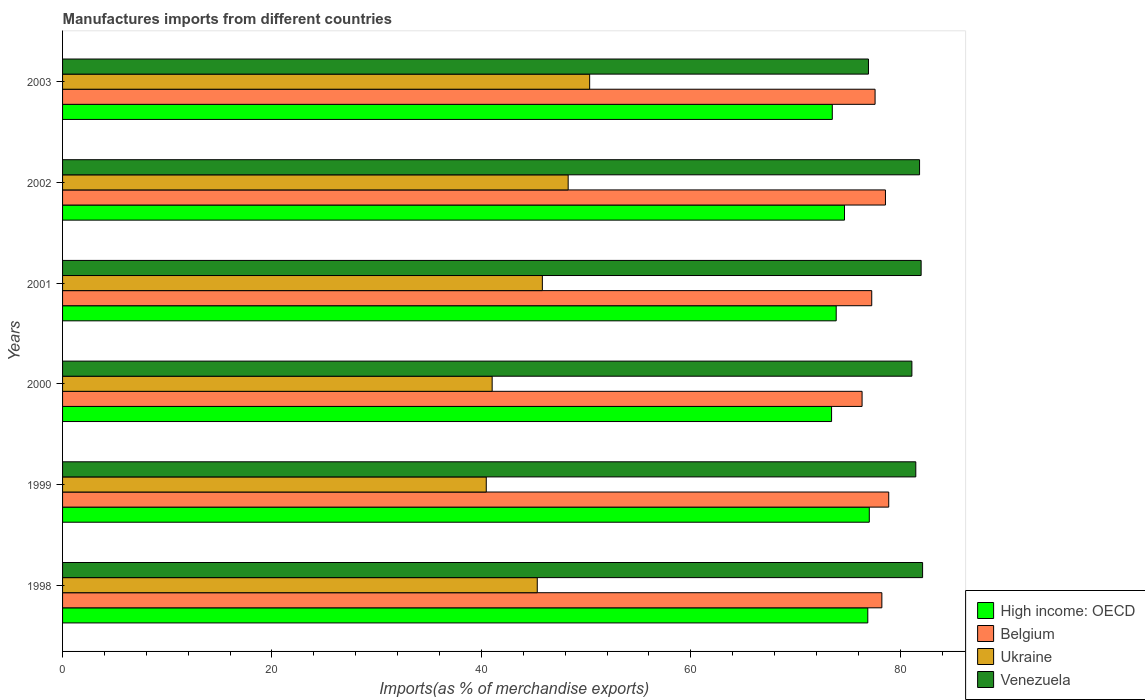What is the label of the 4th group of bars from the top?
Keep it short and to the point. 2000. What is the percentage of imports to different countries in Belgium in 2001?
Give a very brief answer. 77.28. Across all years, what is the maximum percentage of imports to different countries in Venezuela?
Ensure brevity in your answer.  82.14. Across all years, what is the minimum percentage of imports to different countries in Ukraine?
Make the answer very short. 40.46. What is the total percentage of imports to different countries in High income: OECD in the graph?
Your answer should be very brief. 449.47. What is the difference between the percentage of imports to different countries in Venezuela in 2001 and that in 2003?
Offer a terse response. 5.03. What is the difference between the percentage of imports to different countries in High income: OECD in 2001 and the percentage of imports to different countries in Belgium in 2002?
Provide a short and direct response. -4.71. What is the average percentage of imports to different countries in Belgium per year?
Give a very brief answer. 77.83. In the year 2002, what is the difference between the percentage of imports to different countries in Ukraine and percentage of imports to different countries in Belgium?
Ensure brevity in your answer.  -30.3. In how many years, is the percentage of imports to different countries in Belgium greater than 52 %?
Provide a succinct answer. 6. What is the ratio of the percentage of imports to different countries in Ukraine in 2001 to that in 2003?
Keep it short and to the point. 0.91. What is the difference between the highest and the second highest percentage of imports to different countries in Belgium?
Give a very brief answer. 0.31. What is the difference between the highest and the lowest percentage of imports to different countries in Belgium?
Your answer should be compact. 2.55. Is it the case that in every year, the sum of the percentage of imports to different countries in High income: OECD and percentage of imports to different countries in Venezuela is greater than the sum of percentage of imports to different countries in Ukraine and percentage of imports to different countries in Belgium?
Provide a succinct answer. No. What does the 1st bar from the bottom in 2000 represents?
Provide a short and direct response. High income: OECD. Is it the case that in every year, the sum of the percentage of imports to different countries in Ukraine and percentage of imports to different countries in Belgium is greater than the percentage of imports to different countries in Venezuela?
Keep it short and to the point. Yes. How many years are there in the graph?
Your response must be concise. 6. Does the graph contain any zero values?
Keep it short and to the point. No. Does the graph contain grids?
Provide a short and direct response. No. Where does the legend appear in the graph?
Provide a short and direct response. Bottom right. What is the title of the graph?
Provide a short and direct response. Manufactures imports from different countries. Does "Barbados" appear as one of the legend labels in the graph?
Offer a terse response. No. What is the label or title of the X-axis?
Offer a very short reply. Imports(as % of merchandise exports). What is the label or title of the Y-axis?
Make the answer very short. Years. What is the Imports(as % of merchandise exports) of High income: OECD in 1998?
Offer a terse response. 76.9. What is the Imports(as % of merchandise exports) in Belgium in 1998?
Your answer should be compact. 78.25. What is the Imports(as % of merchandise exports) in Ukraine in 1998?
Provide a succinct answer. 45.34. What is the Imports(as % of merchandise exports) in Venezuela in 1998?
Provide a succinct answer. 82.14. What is the Imports(as % of merchandise exports) of High income: OECD in 1999?
Your answer should be very brief. 77.05. What is the Imports(as % of merchandise exports) of Belgium in 1999?
Keep it short and to the point. 78.9. What is the Imports(as % of merchandise exports) of Ukraine in 1999?
Make the answer very short. 40.46. What is the Imports(as % of merchandise exports) in Venezuela in 1999?
Your response must be concise. 81.49. What is the Imports(as % of merchandise exports) in High income: OECD in 2000?
Give a very brief answer. 73.44. What is the Imports(as % of merchandise exports) in Belgium in 2000?
Your response must be concise. 76.36. What is the Imports(as % of merchandise exports) of Ukraine in 2000?
Your answer should be compact. 41.03. What is the Imports(as % of merchandise exports) in Venezuela in 2000?
Offer a very short reply. 81.12. What is the Imports(as % of merchandise exports) of High income: OECD in 2001?
Provide a succinct answer. 73.89. What is the Imports(as % of merchandise exports) of Belgium in 2001?
Provide a succinct answer. 77.28. What is the Imports(as % of merchandise exports) in Ukraine in 2001?
Make the answer very short. 45.82. What is the Imports(as % of merchandise exports) of Venezuela in 2001?
Your answer should be compact. 82. What is the Imports(as % of merchandise exports) in High income: OECD in 2002?
Your response must be concise. 74.68. What is the Imports(as % of merchandise exports) in Belgium in 2002?
Your response must be concise. 78.59. What is the Imports(as % of merchandise exports) of Ukraine in 2002?
Your answer should be compact. 48.29. What is the Imports(as % of merchandise exports) of Venezuela in 2002?
Provide a short and direct response. 81.85. What is the Imports(as % of merchandise exports) of High income: OECD in 2003?
Offer a very short reply. 73.51. What is the Imports(as % of merchandise exports) in Belgium in 2003?
Offer a terse response. 77.6. What is the Imports(as % of merchandise exports) in Ukraine in 2003?
Your answer should be compact. 50.34. What is the Imports(as % of merchandise exports) of Venezuela in 2003?
Offer a very short reply. 76.97. Across all years, what is the maximum Imports(as % of merchandise exports) in High income: OECD?
Give a very brief answer. 77.05. Across all years, what is the maximum Imports(as % of merchandise exports) of Belgium?
Your answer should be very brief. 78.9. Across all years, what is the maximum Imports(as % of merchandise exports) in Ukraine?
Keep it short and to the point. 50.34. Across all years, what is the maximum Imports(as % of merchandise exports) in Venezuela?
Your answer should be compact. 82.14. Across all years, what is the minimum Imports(as % of merchandise exports) of High income: OECD?
Provide a succinct answer. 73.44. Across all years, what is the minimum Imports(as % of merchandise exports) in Belgium?
Make the answer very short. 76.36. Across all years, what is the minimum Imports(as % of merchandise exports) in Ukraine?
Provide a short and direct response. 40.46. Across all years, what is the minimum Imports(as % of merchandise exports) of Venezuela?
Offer a very short reply. 76.97. What is the total Imports(as % of merchandise exports) of High income: OECD in the graph?
Offer a very short reply. 449.47. What is the total Imports(as % of merchandise exports) in Belgium in the graph?
Provide a succinct answer. 466.98. What is the total Imports(as % of merchandise exports) in Ukraine in the graph?
Offer a terse response. 271.28. What is the total Imports(as % of merchandise exports) of Venezuela in the graph?
Your answer should be very brief. 485.56. What is the difference between the Imports(as % of merchandise exports) of High income: OECD in 1998 and that in 1999?
Your answer should be compact. -0.14. What is the difference between the Imports(as % of merchandise exports) in Belgium in 1998 and that in 1999?
Give a very brief answer. -0.66. What is the difference between the Imports(as % of merchandise exports) in Ukraine in 1998 and that in 1999?
Offer a very short reply. 4.87. What is the difference between the Imports(as % of merchandise exports) of Venezuela in 1998 and that in 1999?
Your answer should be compact. 0.65. What is the difference between the Imports(as % of merchandise exports) of High income: OECD in 1998 and that in 2000?
Provide a short and direct response. 3.46. What is the difference between the Imports(as % of merchandise exports) of Belgium in 1998 and that in 2000?
Give a very brief answer. 1.89. What is the difference between the Imports(as % of merchandise exports) of Ukraine in 1998 and that in 2000?
Your answer should be very brief. 4.31. What is the difference between the Imports(as % of merchandise exports) of Venezuela in 1998 and that in 2000?
Your answer should be compact. 1.02. What is the difference between the Imports(as % of merchandise exports) of High income: OECD in 1998 and that in 2001?
Offer a terse response. 3.02. What is the difference between the Imports(as % of merchandise exports) of Belgium in 1998 and that in 2001?
Your answer should be compact. 0.97. What is the difference between the Imports(as % of merchandise exports) of Ukraine in 1998 and that in 2001?
Your answer should be compact. -0.49. What is the difference between the Imports(as % of merchandise exports) of Venezuela in 1998 and that in 2001?
Provide a short and direct response. 0.14. What is the difference between the Imports(as % of merchandise exports) in High income: OECD in 1998 and that in 2002?
Give a very brief answer. 2.23. What is the difference between the Imports(as % of merchandise exports) in Belgium in 1998 and that in 2002?
Offer a terse response. -0.34. What is the difference between the Imports(as % of merchandise exports) of Ukraine in 1998 and that in 2002?
Your answer should be compact. -2.95. What is the difference between the Imports(as % of merchandise exports) in Venezuela in 1998 and that in 2002?
Your response must be concise. 0.29. What is the difference between the Imports(as % of merchandise exports) in High income: OECD in 1998 and that in 2003?
Your answer should be very brief. 3.39. What is the difference between the Imports(as % of merchandise exports) in Belgium in 1998 and that in 2003?
Provide a succinct answer. 0.65. What is the difference between the Imports(as % of merchandise exports) in Ukraine in 1998 and that in 2003?
Offer a terse response. -5. What is the difference between the Imports(as % of merchandise exports) of Venezuela in 1998 and that in 2003?
Your answer should be compact. 5.17. What is the difference between the Imports(as % of merchandise exports) of High income: OECD in 1999 and that in 2000?
Make the answer very short. 3.6. What is the difference between the Imports(as % of merchandise exports) in Belgium in 1999 and that in 2000?
Your answer should be compact. 2.55. What is the difference between the Imports(as % of merchandise exports) of Ukraine in 1999 and that in 2000?
Your answer should be very brief. -0.56. What is the difference between the Imports(as % of merchandise exports) in Venezuela in 1999 and that in 2000?
Your answer should be compact. 0.37. What is the difference between the Imports(as % of merchandise exports) in High income: OECD in 1999 and that in 2001?
Offer a very short reply. 3.16. What is the difference between the Imports(as % of merchandise exports) of Belgium in 1999 and that in 2001?
Make the answer very short. 1.62. What is the difference between the Imports(as % of merchandise exports) of Ukraine in 1999 and that in 2001?
Provide a short and direct response. -5.36. What is the difference between the Imports(as % of merchandise exports) in Venezuela in 1999 and that in 2001?
Provide a succinct answer. -0.51. What is the difference between the Imports(as % of merchandise exports) of High income: OECD in 1999 and that in 2002?
Your response must be concise. 2.37. What is the difference between the Imports(as % of merchandise exports) of Belgium in 1999 and that in 2002?
Provide a succinct answer. 0.31. What is the difference between the Imports(as % of merchandise exports) of Ukraine in 1999 and that in 2002?
Keep it short and to the point. -7.82. What is the difference between the Imports(as % of merchandise exports) of Venezuela in 1999 and that in 2002?
Ensure brevity in your answer.  -0.36. What is the difference between the Imports(as % of merchandise exports) in High income: OECD in 1999 and that in 2003?
Keep it short and to the point. 3.53. What is the difference between the Imports(as % of merchandise exports) in Belgium in 1999 and that in 2003?
Offer a very short reply. 1.3. What is the difference between the Imports(as % of merchandise exports) in Ukraine in 1999 and that in 2003?
Make the answer very short. -9.87. What is the difference between the Imports(as % of merchandise exports) of Venezuela in 1999 and that in 2003?
Offer a very short reply. 4.52. What is the difference between the Imports(as % of merchandise exports) of High income: OECD in 2000 and that in 2001?
Your answer should be compact. -0.44. What is the difference between the Imports(as % of merchandise exports) of Belgium in 2000 and that in 2001?
Provide a succinct answer. -0.92. What is the difference between the Imports(as % of merchandise exports) in Ukraine in 2000 and that in 2001?
Offer a terse response. -4.8. What is the difference between the Imports(as % of merchandise exports) in Venezuela in 2000 and that in 2001?
Provide a short and direct response. -0.88. What is the difference between the Imports(as % of merchandise exports) of High income: OECD in 2000 and that in 2002?
Offer a terse response. -1.23. What is the difference between the Imports(as % of merchandise exports) in Belgium in 2000 and that in 2002?
Keep it short and to the point. -2.23. What is the difference between the Imports(as % of merchandise exports) of Ukraine in 2000 and that in 2002?
Provide a succinct answer. -7.26. What is the difference between the Imports(as % of merchandise exports) of Venezuela in 2000 and that in 2002?
Provide a succinct answer. -0.73. What is the difference between the Imports(as % of merchandise exports) of High income: OECD in 2000 and that in 2003?
Provide a short and direct response. -0.07. What is the difference between the Imports(as % of merchandise exports) in Belgium in 2000 and that in 2003?
Your answer should be very brief. -1.24. What is the difference between the Imports(as % of merchandise exports) of Ukraine in 2000 and that in 2003?
Offer a very short reply. -9.31. What is the difference between the Imports(as % of merchandise exports) in Venezuela in 2000 and that in 2003?
Make the answer very short. 4.15. What is the difference between the Imports(as % of merchandise exports) in High income: OECD in 2001 and that in 2002?
Your response must be concise. -0.79. What is the difference between the Imports(as % of merchandise exports) in Belgium in 2001 and that in 2002?
Ensure brevity in your answer.  -1.31. What is the difference between the Imports(as % of merchandise exports) of Ukraine in 2001 and that in 2002?
Your answer should be compact. -2.47. What is the difference between the Imports(as % of merchandise exports) in Venezuela in 2001 and that in 2002?
Your answer should be very brief. 0.15. What is the difference between the Imports(as % of merchandise exports) in High income: OECD in 2001 and that in 2003?
Offer a terse response. 0.37. What is the difference between the Imports(as % of merchandise exports) of Belgium in 2001 and that in 2003?
Your answer should be very brief. -0.32. What is the difference between the Imports(as % of merchandise exports) of Ukraine in 2001 and that in 2003?
Your response must be concise. -4.52. What is the difference between the Imports(as % of merchandise exports) of Venezuela in 2001 and that in 2003?
Provide a succinct answer. 5.03. What is the difference between the Imports(as % of merchandise exports) in High income: OECD in 2002 and that in 2003?
Your answer should be compact. 1.16. What is the difference between the Imports(as % of merchandise exports) of Ukraine in 2002 and that in 2003?
Your response must be concise. -2.05. What is the difference between the Imports(as % of merchandise exports) of Venezuela in 2002 and that in 2003?
Your answer should be very brief. 4.88. What is the difference between the Imports(as % of merchandise exports) of High income: OECD in 1998 and the Imports(as % of merchandise exports) of Belgium in 1999?
Your answer should be compact. -2. What is the difference between the Imports(as % of merchandise exports) in High income: OECD in 1998 and the Imports(as % of merchandise exports) in Ukraine in 1999?
Make the answer very short. 36.44. What is the difference between the Imports(as % of merchandise exports) in High income: OECD in 1998 and the Imports(as % of merchandise exports) in Venezuela in 1999?
Provide a succinct answer. -4.58. What is the difference between the Imports(as % of merchandise exports) of Belgium in 1998 and the Imports(as % of merchandise exports) of Ukraine in 1999?
Provide a short and direct response. 37.78. What is the difference between the Imports(as % of merchandise exports) in Belgium in 1998 and the Imports(as % of merchandise exports) in Venezuela in 1999?
Ensure brevity in your answer.  -3.24. What is the difference between the Imports(as % of merchandise exports) of Ukraine in 1998 and the Imports(as % of merchandise exports) of Venezuela in 1999?
Offer a terse response. -36.15. What is the difference between the Imports(as % of merchandise exports) of High income: OECD in 1998 and the Imports(as % of merchandise exports) of Belgium in 2000?
Provide a succinct answer. 0.55. What is the difference between the Imports(as % of merchandise exports) of High income: OECD in 1998 and the Imports(as % of merchandise exports) of Ukraine in 2000?
Keep it short and to the point. 35.88. What is the difference between the Imports(as % of merchandise exports) of High income: OECD in 1998 and the Imports(as % of merchandise exports) of Venezuela in 2000?
Make the answer very short. -4.21. What is the difference between the Imports(as % of merchandise exports) of Belgium in 1998 and the Imports(as % of merchandise exports) of Ukraine in 2000?
Provide a short and direct response. 37.22. What is the difference between the Imports(as % of merchandise exports) of Belgium in 1998 and the Imports(as % of merchandise exports) of Venezuela in 2000?
Keep it short and to the point. -2.87. What is the difference between the Imports(as % of merchandise exports) in Ukraine in 1998 and the Imports(as % of merchandise exports) in Venezuela in 2000?
Offer a very short reply. -35.78. What is the difference between the Imports(as % of merchandise exports) in High income: OECD in 1998 and the Imports(as % of merchandise exports) in Belgium in 2001?
Keep it short and to the point. -0.38. What is the difference between the Imports(as % of merchandise exports) in High income: OECD in 1998 and the Imports(as % of merchandise exports) in Ukraine in 2001?
Keep it short and to the point. 31.08. What is the difference between the Imports(as % of merchandise exports) in High income: OECD in 1998 and the Imports(as % of merchandise exports) in Venezuela in 2001?
Make the answer very short. -5.09. What is the difference between the Imports(as % of merchandise exports) in Belgium in 1998 and the Imports(as % of merchandise exports) in Ukraine in 2001?
Your answer should be very brief. 32.42. What is the difference between the Imports(as % of merchandise exports) in Belgium in 1998 and the Imports(as % of merchandise exports) in Venezuela in 2001?
Give a very brief answer. -3.75. What is the difference between the Imports(as % of merchandise exports) in Ukraine in 1998 and the Imports(as % of merchandise exports) in Venezuela in 2001?
Provide a succinct answer. -36.66. What is the difference between the Imports(as % of merchandise exports) in High income: OECD in 1998 and the Imports(as % of merchandise exports) in Belgium in 2002?
Your answer should be compact. -1.69. What is the difference between the Imports(as % of merchandise exports) of High income: OECD in 1998 and the Imports(as % of merchandise exports) of Ukraine in 2002?
Your answer should be compact. 28.62. What is the difference between the Imports(as % of merchandise exports) in High income: OECD in 1998 and the Imports(as % of merchandise exports) in Venezuela in 2002?
Give a very brief answer. -4.94. What is the difference between the Imports(as % of merchandise exports) in Belgium in 1998 and the Imports(as % of merchandise exports) in Ukraine in 2002?
Keep it short and to the point. 29.96. What is the difference between the Imports(as % of merchandise exports) in Belgium in 1998 and the Imports(as % of merchandise exports) in Venezuela in 2002?
Offer a very short reply. -3.6. What is the difference between the Imports(as % of merchandise exports) in Ukraine in 1998 and the Imports(as % of merchandise exports) in Venezuela in 2002?
Your response must be concise. -36.51. What is the difference between the Imports(as % of merchandise exports) of High income: OECD in 1998 and the Imports(as % of merchandise exports) of Belgium in 2003?
Your answer should be compact. -0.7. What is the difference between the Imports(as % of merchandise exports) of High income: OECD in 1998 and the Imports(as % of merchandise exports) of Ukraine in 2003?
Your answer should be very brief. 26.57. What is the difference between the Imports(as % of merchandise exports) in High income: OECD in 1998 and the Imports(as % of merchandise exports) in Venezuela in 2003?
Provide a succinct answer. -0.06. What is the difference between the Imports(as % of merchandise exports) in Belgium in 1998 and the Imports(as % of merchandise exports) in Ukraine in 2003?
Your answer should be compact. 27.91. What is the difference between the Imports(as % of merchandise exports) in Belgium in 1998 and the Imports(as % of merchandise exports) in Venezuela in 2003?
Keep it short and to the point. 1.28. What is the difference between the Imports(as % of merchandise exports) in Ukraine in 1998 and the Imports(as % of merchandise exports) in Venezuela in 2003?
Your answer should be very brief. -31.63. What is the difference between the Imports(as % of merchandise exports) in High income: OECD in 1999 and the Imports(as % of merchandise exports) in Belgium in 2000?
Provide a short and direct response. 0.69. What is the difference between the Imports(as % of merchandise exports) in High income: OECD in 1999 and the Imports(as % of merchandise exports) in Ukraine in 2000?
Offer a very short reply. 36.02. What is the difference between the Imports(as % of merchandise exports) in High income: OECD in 1999 and the Imports(as % of merchandise exports) in Venezuela in 2000?
Provide a short and direct response. -4.07. What is the difference between the Imports(as % of merchandise exports) in Belgium in 1999 and the Imports(as % of merchandise exports) in Ukraine in 2000?
Offer a very short reply. 37.88. What is the difference between the Imports(as % of merchandise exports) in Belgium in 1999 and the Imports(as % of merchandise exports) in Venezuela in 2000?
Your answer should be compact. -2.21. What is the difference between the Imports(as % of merchandise exports) of Ukraine in 1999 and the Imports(as % of merchandise exports) of Venezuela in 2000?
Offer a very short reply. -40.65. What is the difference between the Imports(as % of merchandise exports) of High income: OECD in 1999 and the Imports(as % of merchandise exports) of Belgium in 2001?
Give a very brief answer. -0.23. What is the difference between the Imports(as % of merchandise exports) in High income: OECD in 1999 and the Imports(as % of merchandise exports) in Ukraine in 2001?
Give a very brief answer. 31.22. What is the difference between the Imports(as % of merchandise exports) of High income: OECD in 1999 and the Imports(as % of merchandise exports) of Venezuela in 2001?
Your answer should be compact. -4.95. What is the difference between the Imports(as % of merchandise exports) of Belgium in 1999 and the Imports(as % of merchandise exports) of Ukraine in 2001?
Give a very brief answer. 33.08. What is the difference between the Imports(as % of merchandise exports) of Belgium in 1999 and the Imports(as % of merchandise exports) of Venezuela in 2001?
Make the answer very short. -3.1. What is the difference between the Imports(as % of merchandise exports) of Ukraine in 1999 and the Imports(as % of merchandise exports) of Venezuela in 2001?
Make the answer very short. -41.53. What is the difference between the Imports(as % of merchandise exports) in High income: OECD in 1999 and the Imports(as % of merchandise exports) in Belgium in 2002?
Provide a short and direct response. -1.54. What is the difference between the Imports(as % of merchandise exports) of High income: OECD in 1999 and the Imports(as % of merchandise exports) of Ukraine in 2002?
Make the answer very short. 28.76. What is the difference between the Imports(as % of merchandise exports) of High income: OECD in 1999 and the Imports(as % of merchandise exports) of Venezuela in 2002?
Your answer should be very brief. -4.8. What is the difference between the Imports(as % of merchandise exports) of Belgium in 1999 and the Imports(as % of merchandise exports) of Ukraine in 2002?
Your response must be concise. 30.61. What is the difference between the Imports(as % of merchandise exports) in Belgium in 1999 and the Imports(as % of merchandise exports) in Venezuela in 2002?
Your response must be concise. -2.94. What is the difference between the Imports(as % of merchandise exports) in Ukraine in 1999 and the Imports(as % of merchandise exports) in Venezuela in 2002?
Your answer should be compact. -41.38. What is the difference between the Imports(as % of merchandise exports) of High income: OECD in 1999 and the Imports(as % of merchandise exports) of Belgium in 2003?
Offer a terse response. -0.55. What is the difference between the Imports(as % of merchandise exports) in High income: OECD in 1999 and the Imports(as % of merchandise exports) in Ukraine in 2003?
Ensure brevity in your answer.  26.71. What is the difference between the Imports(as % of merchandise exports) of High income: OECD in 1999 and the Imports(as % of merchandise exports) of Venezuela in 2003?
Your response must be concise. 0.08. What is the difference between the Imports(as % of merchandise exports) in Belgium in 1999 and the Imports(as % of merchandise exports) in Ukraine in 2003?
Your answer should be compact. 28.56. What is the difference between the Imports(as % of merchandise exports) in Belgium in 1999 and the Imports(as % of merchandise exports) in Venezuela in 2003?
Your answer should be compact. 1.94. What is the difference between the Imports(as % of merchandise exports) of Ukraine in 1999 and the Imports(as % of merchandise exports) of Venezuela in 2003?
Ensure brevity in your answer.  -36.5. What is the difference between the Imports(as % of merchandise exports) in High income: OECD in 2000 and the Imports(as % of merchandise exports) in Belgium in 2001?
Offer a very short reply. -3.84. What is the difference between the Imports(as % of merchandise exports) in High income: OECD in 2000 and the Imports(as % of merchandise exports) in Ukraine in 2001?
Provide a succinct answer. 27.62. What is the difference between the Imports(as % of merchandise exports) in High income: OECD in 2000 and the Imports(as % of merchandise exports) in Venezuela in 2001?
Offer a very short reply. -8.55. What is the difference between the Imports(as % of merchandise exports) of Belgium in 2000 and the Imports(as % of merchandise exports) of Ukraine in 2001?
Provide a succinct answer. 30.53. What is the difference between the Imports(as % of merchandise exports) of Belgium in 2000 and the Imports(as % of merchandise exports) of Venezuela in 2001?
Offer a terse response. -5.64. What is the difference between the Imports(as % of merchandise exports) of Ukraine in 2000 and the Imports(as % of merchandise exports) of Venezuela in 2001?
Your answer should be very brief. -40.97. What is the difference between the Imports(as % of merchandise exports) of High income: OECD in 2000 and the Imports(as % of merchandise exports) of Belgium in 2002?
Provide a succinct answer. -5.15. What is the difference between the Imports(as % of merchandise exports) in High income: OECD in 2000 and the Imports(as % of merchandise exports) in Ukraine in 2002?
Provide a short and direct response. 25.16. What is the difference between the Imports(as % of merchandise exports) in High income: OECD in 2000 and the Imports(as % of merchandise exports) in Venezuela in 2002?
Provide a short and direct response. -8.4. What is the difference between the Imports(as % of merchandise exports) in Belgium in 2000 and the Imports(as % of merchandise exports) in Ukraine in 2002?
Provide a succinct answer. 28.07. What is the difference between the Imports(as % of merchandise exports) of Belgium in 2000 and the Imports(as % of merchandise exports) of Venezuela in 2002?
Keep it short and to the point. -5.49. What is the difference between the Imports(as % of merchandise exports) in Ukraine in 2000 and the Imports(as % of merchandise exports) in Venezuela in 2002?
Your answer should be very brief. -40.82. What is the difference between the Imports(as % of merchandise exports) in High income: OECD in 2000 and the Imports(as % of merchandise exports) in Belgium in 2003?
Offer a very short reply. -4.16. What is the difference between the Imports(as % of merchandise exports) in High income: OECD in 2000 and the Imports(as % of merchandise exports) in Ukraine in 2003?
Your answer should be very brief. 23.1. What is the difference between the Imports(as % of merchandise exports) in High income: OECD in 2000 and the Imports(as % of merchandise exports) in Venezuela in 2003?
Make the answer very short. -3.52. What is the difference between the Imports(as % of merchandise exports) of Belgium in 2000 and the Imports(as % of merchandise exports) of Ukraine in 2003?
Offer a very short reply. 26.02. What is the difference between the Imports(as % of merchandise exports) of Belgium in 2000 and the Imports(as % of merchandise exports) of Venezuela in 2003?
Ensure brevity in your answer.  -0.61. What is the difference between the Imports(as % of merchandise exports) in Ukraine in 2000 and the Imports(as % of merchandise exports) in Venezuela in 2003?
Your response must be concise. -35.94. What is the difference between the Imports(as % of merchandise exports) in High income: OECD in 2001 and the Imports(as % of merchandise exports) in Belgium in 2002?
Your answer should be very brief. -4.71. What is the difference between the Imports(as % of merchandise exports) in High income: OECD in 2001 and the Imports(as % of merchandise exports) in Ukraine in 2002?
Make the answer very short. 25.6. What is the difference between the Imports(as % of merchandise exports) of High income: OECD in 2001 and the Imports(as % of merchandise exports) of Venezuela in 2002?
Provide a succinct answer. -7.96. What is the difference between the Imports(as % of merchandise exports) in Belgium in 2001 and the Imports(as % of merchandise exports) in Ukraine in 2002?
Ensure brevity in your answer.  28.99. What is the difference between the Imports(as % of merchandise exports) in Belgium in 2001 and the Imports(as % of merchandise exports) in Venezuela in 2002?
Your response must be concise. -4.57. What is the difference between the Imports(as % of merchandise exports) in Ukraine in 2001 and the Imports(as % of merchandise exports) in Venezuela in 2002?
Your answer should be compact. -36.02. What is the difference between the Imports(as % of merchandise exports) of High income: OECD in 2001 and the Imports(as % of merchandise exports) of Belgium in 2003?
Give a very brief answer. -3.71. What is the difference between the Imports(as % of merchandise exports) in High income: OECD in 2001 and the Imports(as % of merchandise exports) in Ukraine in 2003?
Offer a terse response. 23.55. What is the difference between the Imports(as % of merchandise exports) of High income: OECD in 2001 and the Imports(as % of merchandise exports) of Venezuela in 2003?
Offer a terse response. -3.08. What is the difference between the Imports(as % of merchandise exports) in Belgium in 2001 and the Imports(as % of merchandise exports) in Ukraine in 2003?
Provide a short and direct response. 26.94. What is the difference between the Imports(as % of merchandise exports) of Belgium in 2001 and the Imports(as % of merchandise exports) of Venezuela in 2003?
Your response must be concise. 0.31. What is the difference between the Imports(as % of merchandise exports) of Ukraine in 2001 and the Imports(as % of merchandise exports) of Venezuela in 2003?
Keep it short and to the point. -31.14. What is the difference between the Imports(as % of merchandise exports) in High income: OECD in 2002 and the Imports(as % of merchandise exports) in Belgium in 2003?
Your response must be concise. -2.92. What is the difference between the Imports(as % of merchandise exports) in High income: OECD in 2002 and the Imports(as % of merchandise exports) in Ukraine in 2003?
Ensure brevity in your answer.  24.34. What is the difference between the Imports(as % of merchandise exports) in High income: OECD in 2002 and the Imports(as % of merchandise exports) in Venezuela in 2003?
Offer a terse response. -2.29. What is the difference between the Imports(as % of merchandise exports) of Belgium in 2002 and the Imports(as % of merchandise exports) of Ukraine in 2003?
Keep it short and to the point. 28.25. What is the difference between the Imports(as % of merchandise exports) in Belgium in 2002 and the Imports(as % of merchandise exports) in Venezuela in 2003?
Your response must be concise. 1.62. What is the difference between the Imports(as % of merchandise exports) in Ukraine in 2002 and the Imports(as % of merchandise exports) in Venezuela in 2003?
Ensure brevity in your answer.  -28.68. What is the average Imports(as % of merchandise exports) of High income: OECD per year?
Make the answer very short. 74.91. What is the average Imports(as % of merchandise exports) in Belgium per year?
Your response must be concise. 77.83. What is the average Imports(as % of merchandise exports) in Ukraine per year?
Offer a terse response. 45.21. What is the average Imports(as % of merchandise exports) of Venezuela per year?
Give a very brief answer. 80.93. In the year 1998, what is the difference between the Imports(as % of merchandise exports) of High income: OECD and Imports(as % of merchandise exports) of Belgium?
Keep it short and to the point. -1.34. In the year 1998, what is the difference between the Imports(as % of merchandise exports) in High income: OECD and Imports(as % of merchandise exports) in Ukraine?
Offer a very short reply. 31.57. In the year 1998, what is the difference between the Imports(as % of merchandise exports) of High income: OECD and Imports(as % of merchandise exports) of Venezuela?
Make the answer very short. -5.23. In the year 1998, what is the difference between the Imports(as % of merchandise exports) in Belgium and Imports(as % of merchandise exports) in Ukraine?
Offer a very short reply. 32.91. In the year 1998, what is the difference between the Imports(as % of merchandise exports) in Belgium and Imports(as % of merchandise exports) in Venezuela?
Your response must be concise. -3.89. In the year 1998, what is the difference between the Imports(as % of merchandise exports) in Ukraine and Imports(as % of merchandise exports) in Venezuela?
Your answer should be compact. -36.8. In the year 1999, what is the difference between the Imports(as % of merchandise exports) of High income: OECD and Imports(as % of merchandise exports) of Belgium?
Ensure brevity in your answer.  -1.86. In the year 1999, what is the difference between the Imports(as % of merchandise exports) in High income: OECD and Imports(as % of merchandise exports) in Ukraine?
Offer a terse response. 36.58. In the year 1999, what is the difference between the Imports(as % of merchandise exports) of High income: OECD and Imports(as % of merchandise exports) of Venezuela?
Your answer should be compact. -4.44. In the year 1999, what is the difference between the Imports(as % of merchandise exports) in Belgium and Imports(as % of merchandise exports) in Ukraine?
Ensure brevity in your answer.  38.44. In the year 1999, what is the difference between the Imports(as % of merchandise exports) in Belgium and Imports(as % of merchandise exports) in Venezuela?
Make the answer very short. -2.58. In the year 1999, what is the difference between the Imports(as % of merchandise exports) of Ukraine and Imports(as % of merchandise exports) of Venezuela?
Your response must be concise. -41.02. In the year 2000, what is the difference between the Imports(as % of merchandise exports) of High income: OECD and Imports(as % of merchandise exports) of Belgium?
Keep it short and to the point. -2.91. In the year 2000, what is the difference between the Imports(as % of merchandise exports) in High income: OECD and Imports(as % of merchandise exports) in Ukraine?
Offer a very short reply. 32.42. In the year 2000, what is the difference between the Imports(as % of merchandise exports) of High income: OECD and Imports(as % of merchandise exports) of Venezuela?
Keep it short and to the point. -7.67. In the year 2000, what is the difference between the Imports(as % of merchandise exports) in Belgium and Imports(as % of merchandise exports) in Ukraine?
Provide a short and direct response. 35.33. In the year 2000, what is the difference between the Imports(as % of merchandise exports) in Belgium and Imports(as % of merchandise exports) in Venezuela?
Your answer should be compact. -4.76. In the year 2000, what is the difference between the Imports(as % of merchandise exports) in Ukraine and Imports(as % of merchandise exports) in Venezuela?
Offer a terse response. -40.09. In the year 2001, what is the difference between the Imports(as % of merchandise exports) in High income: OECD and Imports(as % of merchandise exports) in Belgium?
Offer a terse response. -3.39. In the year 2001, what is the difference between the Imports(as % of merchandise exports) in High income: OECD and Imports(as % of merchandise exports) in Ukraine?
Your answer should be compact. 28.06. In the year 2001, what is the difference between the Imports(as % of merchandise exports) in High income: OECD and Imports(as % of merchandise exports) in Venezuela?
Your response must be concise. -8.11. In the year 2001, what is the difference between the Imports(as % of merchandise exports) in Belgium and Imports(as % of merchandise exports) in Ukraine?
Provide a succinct answer. 31.46. In the year 2001, what is the difference between the Imports(as % of merchandise exports) in Belgium and Imports(as % of merchandise exports) in Venezuela?
Provide a succinct answer. -4.72. In the year 2001, what is the difference between the Imports(as % of merchandise exports) in Ukraine and Imports(as % of merchandise exports) in Venezuela?
Your answer should be compact. -36.18. In the year 2002, what is the difference between the Imports(as % of merchandise exports) of High income: OECD and Imports(as % of merchandise exports) of Belgium?
Offer a terse response. -3.91. In the year 2002, what is the difference between the Imports(as % of merchandise exports) in High income: OECD and Imports(as % of merchandise exports) in Ukraine?
Provide a short and direct response. 26.39. In the year 2002, what is the difference between the Imports(as % of merchandise exports) in High income: OECD and Imports(as % of merchandise exports) in Venezuela?
Offer a terse response. -7.17. In the year 2002, what is the difference between the Imports(as % of merchandise exports) of Belgium and Imports(as % of merchandise exports) of Ukraine?
Provide a short and direct response. 30.3. In the year 2002, what is the difference between the Imports(as % of merchandise exports) in Belgium and Imports(as % of merchandise exports) in Venezuela?
Keep it short and to the point. -3.26. In the year 2002, what is the difference between the Imports(as % of merchandise exports) in Ukraine and Imports(as % of merchandise exports) in Venezuela?
Your response must be concise. -33.56. In the year 2003, what is the difference between the Imports(as % of merchandise exports) of High income: OECD and Imports(as % of merchandise exports) of Belgium?
Provide a short and direct response. -4.09. In the year 2003, what is the difference between the Imports(as % of merchandise exports) of High income: OECD and Imports(as % of merchandise exports) of Ukraine?
Offer a terse response. 23.17. In the year 2003, what is the difference between the Imports(as % of merchandise exports) in High income: OECD and Imports(as % of merchandise exports) in Venezuela?
Provide a succinct answer. -3.45. In the year 2003, what is the difference between the Imports(as % of merchandise exports) in Belgium and Imports(as % of merchandise exports) in Ukraine?
Provide a succinct answer. 27.26. In the year 2003, what is the difference between the Imports(as % of merchandise exports) in Belgium and Imports(as % of merchandise exports) in Venezuela?
Offer a terse response. 0.63. In the year 2003, what is the difference between the Imports(as % of merchandise exports) of Ukraine and Imports(as % of merchandise exports) of Venezuela?
Give a very brief answer. -26.63. What is the ratio of the Imports(as % of merchandise exports) in Ukraine in 1998 to that in 1999?
Keep it short and to the point. 1.12. What is the ratio of the Imports(as % of merchandise exports) in Venezuela in 1998 to that in 1999?
Keep it short and to the point. 1.01. What is the ratio of the Imports(as % of merchandise exports) of High income: OECD in 1998 to that in 2000?
Ensure brevity in your answer.  1.05. What is the ratio of the Imports(as % of merchandise exports) in Belgium in 1998 to that in 2000?
Keep it short and to the point. 1.02. What is the ratio of the Imports(as % of merchandise exports) in Ukraine in 1998 to that in 2000?
Your answer should be very brief. 1.1. What is the ratio of the Imports(as % of merchandise exports) in Venezuela in 1998 to that in 2000?
Offer a very short reply. 1.01. What is the ratio of the Imports(as % of merchandise exports) of High income: OECD in 1998 to that in 2001?
Make the answer very short. 1.04. What is the ratio of the Imports(as % of merchandise exports) in Belgium in 1998 to that in 2001?
Give a very brief answer. 1.01. What is the ratio of the Imports(as % of merchandise exports) in Ukraine in 1998 to that in 2001?
Offer a very short reply. 0.99. What is the ratio of the Imports(as % of merchandise exports) of High income: OECD in 1998 to that in 2002?
Your answer should be compact. 1.03. What is the ratio of the Imports(as % of merchandise exports) in Belgium in 1998 to that in 2002?
Keep it short and to the point. 1. What is the ratio of the Imports(as % of merchandise exports) of Ukraine in 1998 to that in 2002?
Provide a succinct answer. 0.94. What is the ratio of the Imports(as % of merchandise exports) of Venezuela in 1998 to that in 2002?
Your answer should be compact. 1. What is the ratio of the Imports(as % of merchandise exports) of High income: OECD in 1998 to that in 2003?
Give a very brief answer. 1.05. What is the ratio of the Imports(as % of merchandise exports) of Belgium in 1998 to that in 2003?
Your answer should be very brief. 1.01. What is the ratio of the Imports(as % of merchandise exports) of Ukraine in 1998 to that in 2003?
Offer a very short reply. 0.9. What is the ratio of the Imports(as % of merchandise exports) in Venezuela in 1998 to that in 2003?
Provide a succinct answer. 1.07. What is the ratio of the Imports(as % of merchandise exports) of High income: OECD in 1999 to that in 2000?
Give a very brief answer. 1.05. What is the ratio of the Imports(as % of merchandise exports) in Belgium in 1999 to that in 2000?
Provide a short and direct response. 1.03. What is the ratio of the Imports(as % of merchandise exports) of Ukraine in 1999 to that in 2000?
Provide a succinct answer. 0.99. What is the ratio of the Imports(as % of merchandise exports) in High income: OECD in 1999 to that in 2001?
Offer a terse response. 1.04. What is the ratio of the Imports(as % of merchandise exports) in Belgium in 1999 to that in 2001?
Make the answer very short. 1.02. What is the ratio of the Imports(as % of merchandise exports) of Ukraine in 1999 to that in 2001?
Provide a short and direct response. 0.88. What is the ratio of the Imports(as % of merchandise exports) of Venezuela in 1999 to that in 2001?
Keep it short and to the point. 0.99. What is the ratio of the Imports(as % of merchandise exports) in High income: OECD in 1999 to that in 2002?
Provide a short and direct response. 1.03. What is the ratio of the Imports(as % of merchandise exports) of Belgium in 1999 to that in 2002?
Your answer should be compact. 1. What is the ratio of the Imports(as % of merchandise exports) in Ukraine in 1999 to that in 2002?
Your answer should be very brief. 0.84. What is the ratio of the Imports(as % of merchandise exports) in Venezuela in 1999 to that in 2002?
Offer a terse response. 1. What is the ratio of the Imports(as % of merchandise exports) of High income: OECD in 1999 to that in 2003?
Make the answer very short. 1.05. What is the ratio of the Imports(as % of merchandise exports) in Belgium in 1999 to that in 2003?
Your response must be concise. 1.02. What is the ratio of the Imports(as % of merchandise exports) of Ukraine in 1999 to that in 2003?
Your answer should be very brief. 0.8. What is the ratio of the Imports(as % of merchandise exports) in Venezuela in 1999 to that in 2003?
Offer a terse response. 1.06. What is the ratio of the Imports(as % of merchandise exports) of Ukraine in 2000 to that in 2001?
Your response must be concise. 0.9. What is the ratio of the Imports(as % of merchandise exports) in Venezuela in 2000 to that in 2001?
Your response must be concise. 0.99. What is the ratio of the Imports(as % of merchandise exports) of High income: OECD in 2000 to that in 2002?
Make the answer very short. 0.98. What is the ratio of the Imports(as % of merchandise exports) of Belgium in 2000 to that in 2002?
Make the answer very short. 0.97. What is the ratio of the Imports(as % of merchandise exports) in Ukraine in 2000 to that in 2002?
Offer a terse response. 0.85. What is the ratio of the Imports(as % of merchandise exports) in Venezuela in 2000 to that in 2002?
Give a very brief answer. 0.99. What is the ratio of the Imports(as % of merchandise exports) in Belgium in 2000 to that in 2003?
Your response must be concise. 0.98. What is the ratio of the Imports(as % of merchandise exports) of Ukraine in 2000 to that in 2003?
Provide a short and direct response. 0.81. What is the ratio of the Imports(as % of merchandise exports) in Venezuela in 2000 to that in 2003?
Ensure brevity in your answer.  1.05. What is the ratio of the Imports(as % of merchandise exports) in Belgium in 2001 to that in 2002?
Make the answer very short. 0.98. What is the ratio of the Imports(as % of merchandise exports) of Ukraine in 2001 to that in 2002?
Your response must be concise. 0.95. What is the ratio of the Imports(as % of merchandise exports) of Venezuela in 2001 to that in 2002?
Offer a very short reply. 1. What is the ratio of the Imports(as % of merchandise exports) in High income: OECD in 2001 to that in 2003?
Ensure brevity in your answer.  1.01. What is the ratio of the Imports(as % of merchandise exports) of Ukraine in 2001 to that in 2003?
Your response must be concise. 0.91. What is the ratio of the Imports(as % of merchandise exports) in Venezuela in 2001 to that in 2003?
Offer a terse response. 1.07. What is the ratio of the Imports(as % of merchandise exports) in High income: OECD in 2002 to that in 2003?
Your answer should be very brief. 1.02. What is the ratio of the Imports(as % of merchandise exports) of Belgium in 2002 to that in 2003?
Make the answer very short. 1.01. What is the ratio of the Imports(as % of merchandise exports) in Ukraine in 2002 to that in 2003?
Provide a succinct answer. 0.96. What is the ratio of the Imports(as % of merchandise exports) of Venezuela in 2002 to that in 2003?
Provide a succinct answer. 1.06. What is the difference between the highest and the second highest Imports(as % of merchandise exports) of High income: OECD?
Provide a succinct answer. 0.14. What is the difference between the highest and the second highest Imports(as % of merchandise exports) in Belgium?
Your response must be concise. 0.31. What is the difference between the highest and the second highest Imports(as % of merchandise exports) in Ukraine?
Ensure brevity in your answer.  2.05. What is the difference between the highest and the second highest Imports(as % of merchandise exports) in Venezuela?
Offer a terse response. 0.14. What is the difference between the highest and the lowest Imports(as % of merchandise exports) of High income: OECD?
Your answer should be compact. 3.6. What is the difference between the highest and the lowest Imports(as % of merchandise exports) in Belgium?
Provide a succinct answer. 2.55. What is the difference between the highest and the lowest Imports(as % of merchandise exports) of Ukraine?
Ensure brevity in your answer.  9.87. What is the difference between the highest and the lowest Imports(as % of merchandise exports) in Venezuela?
Keep it short and to the point. 5.17. 